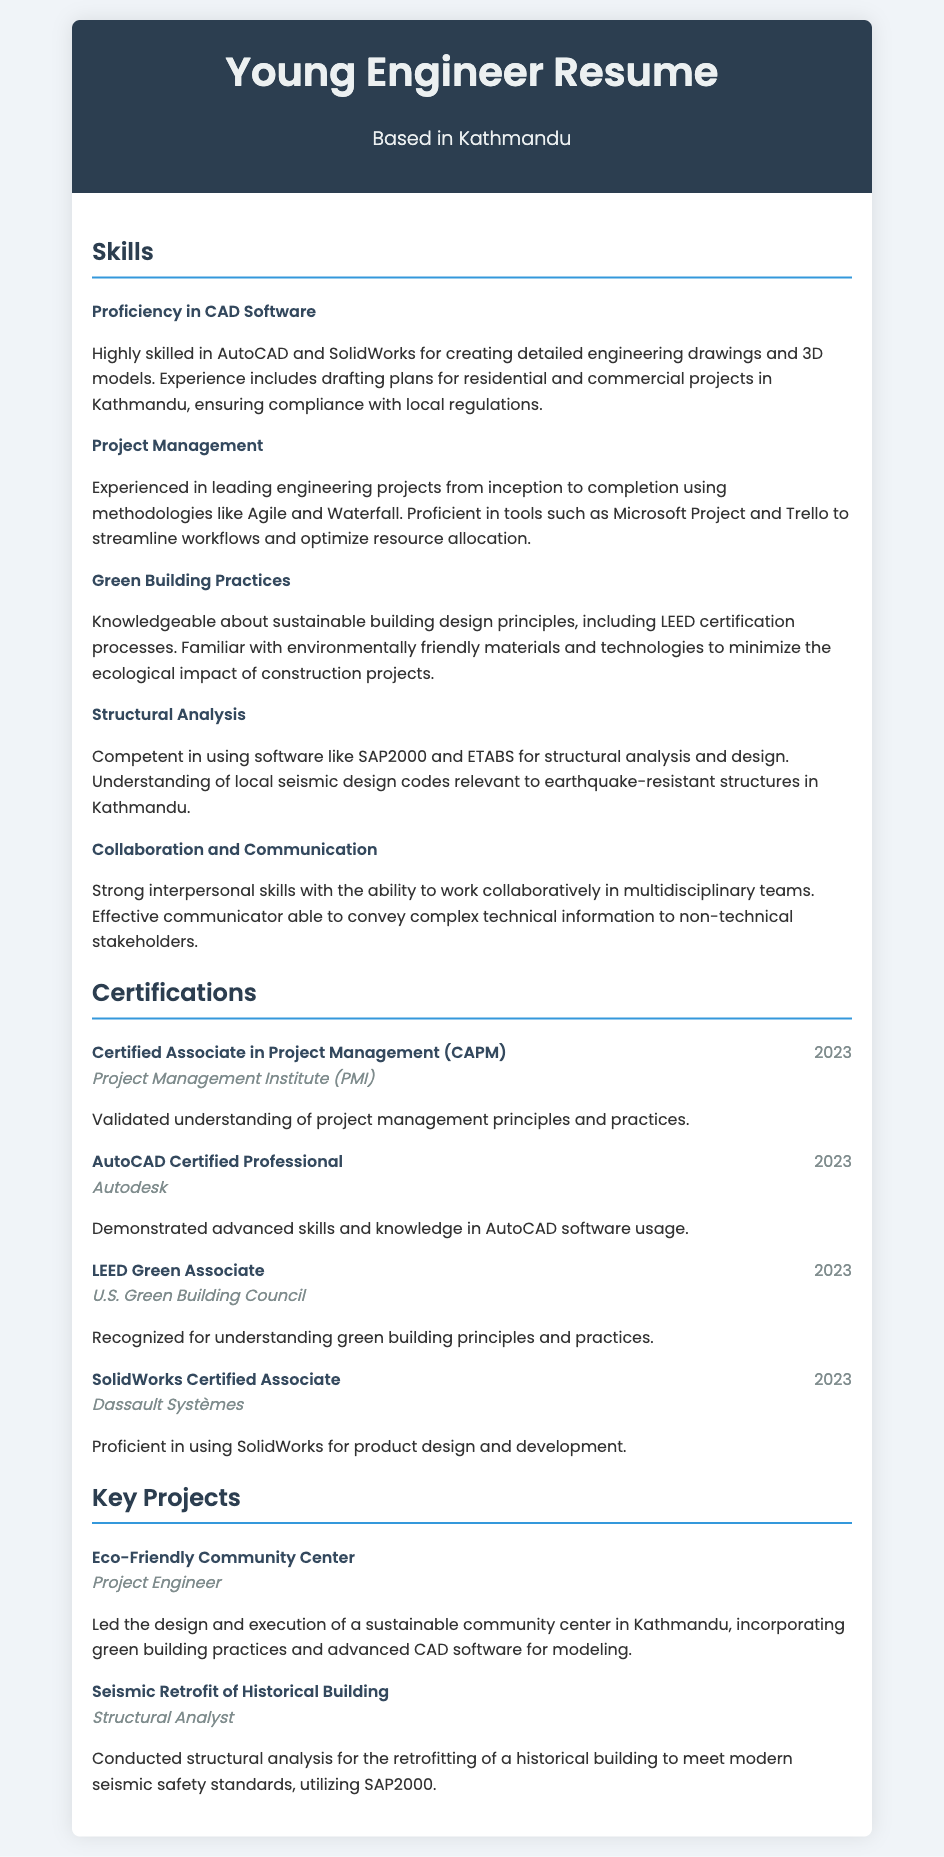What CAD software is mentioned? The CAD software mentioned in the document is AutoCAD and SolidWorks, which are specifically highlighted under the skills section.
Answer: AutoCAD and SolidWorks What year was the AutoCAD Certified Professional certification obtained? The year of obtaining the AutoCAD Certified Professional certification is stated in the certifications section.
Answer: 2023 Who awarded the LEED Green Associate certification? The organization that awarded the LEED Green Associate certification is noted in the certifications section of the document.
Answer: U.S. Green Building Council What project involved green building practices? The project that involved green building practices is highlighted under key projects and is specifically noted for incorporating such principles.
Answer: Eco-Friendly Community Center How many certifications are listed in the document? The total number of certifications is a count of the entries listed in the certifications section.
Answer: Four Which project required structural analysis using SAP2000? The project that required structural analysis using SAP2000 is included in the projects section of the document.
Answer: Seismic Retrofit of Historical Building What is one project management methodology mentioned? The document lists methodologies employed in project management; identifying one of them provides insight into the strategies used.
Answer: Agile What skill indicates collaboration ability? The skill that indicates the ability to collaborate effectively is explicitly mentioned in the skills section, suggesting interpersonal proficiency.
Answer: Collaboration and Communication 